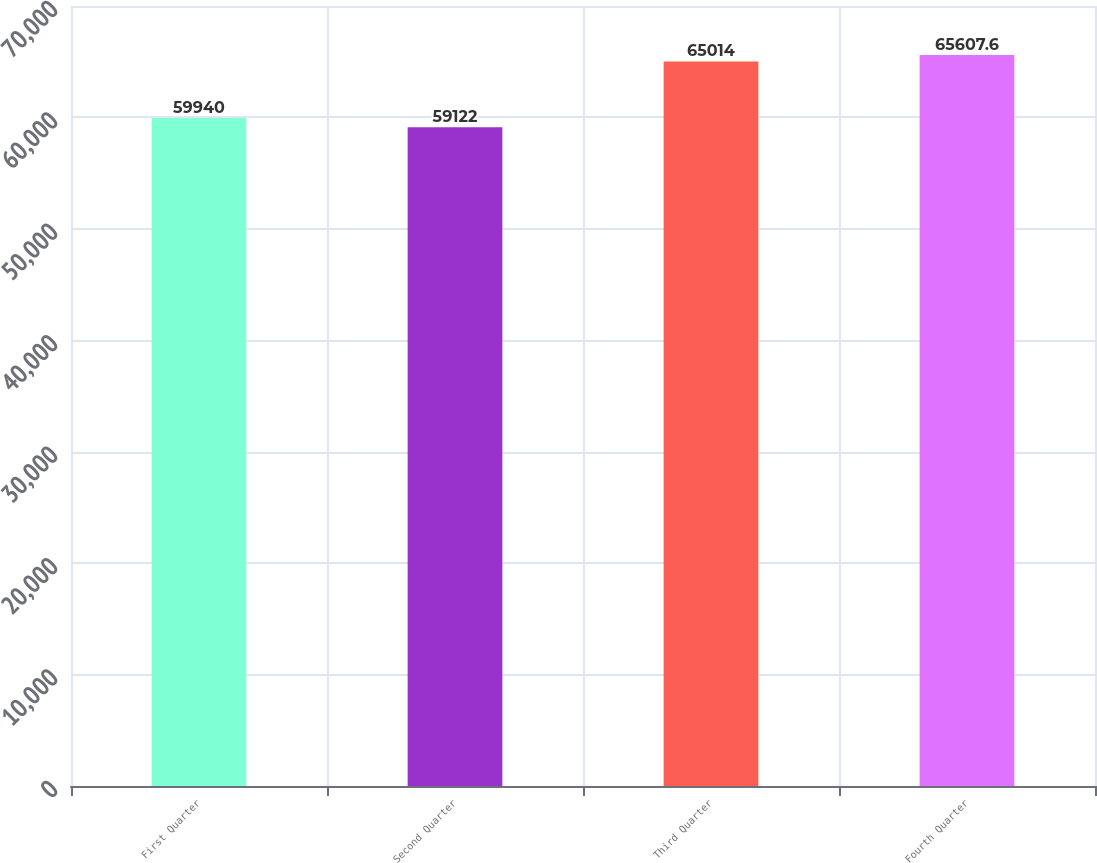Convert chart to OTSL. <chart><loc_0><loc_0><loc_500><loc_500><bar_chart><fcel>First Quarter<fcel>Second Quarter<fcel>Third Quarter<fcel>Fourth Quarter<nl><fcel>59940<fcel>59122<fcel>65014<fcel>65607.6<nl></chart> 